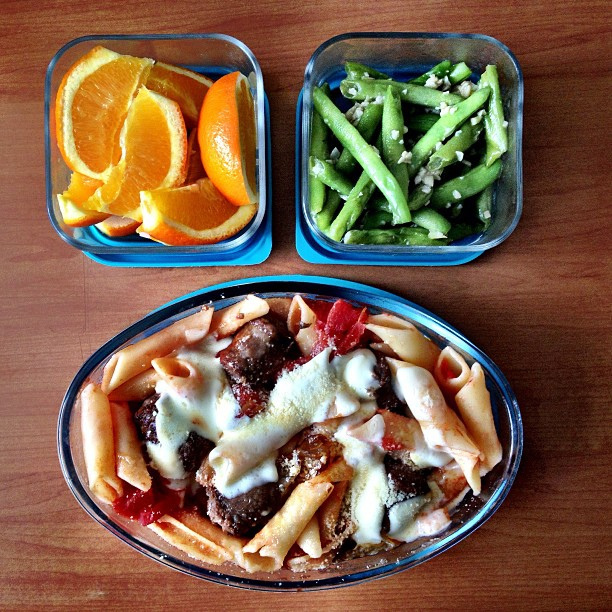Could you suggest a beverage pairing for this meal? Considering the flavors in the meal, a glass of red wine or a light, crisp white wine would complement the tomato-based pasta sauce. For a non-alcoholic option, a sparkling water with a wedge of lemon or lime would provide a refreshing balance. 